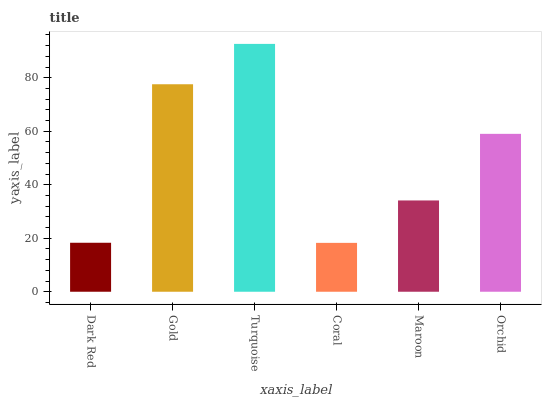Is Gold the minimum?
Answer yes or no. No. Is Gold the maximum?
Answer yes or no. No. Is Gold greater than Dark Red?
Answer yes or no. Yes. Is Dark Red less than Gold?
Answer yes or no. Yes. Is Dark Red greater than Gold?
Answer yes or no. No. Is Gold less than Dark Red?
Answer yes or no. No. Is Orchid the high median?
Answer yes or no. Yes. Is Maroon the low median?
Answer yes or no. Yes. Is Maroon the high median?
Answer yes or no. No. Is Turquoise the low median?
Answer yes or no. No. 